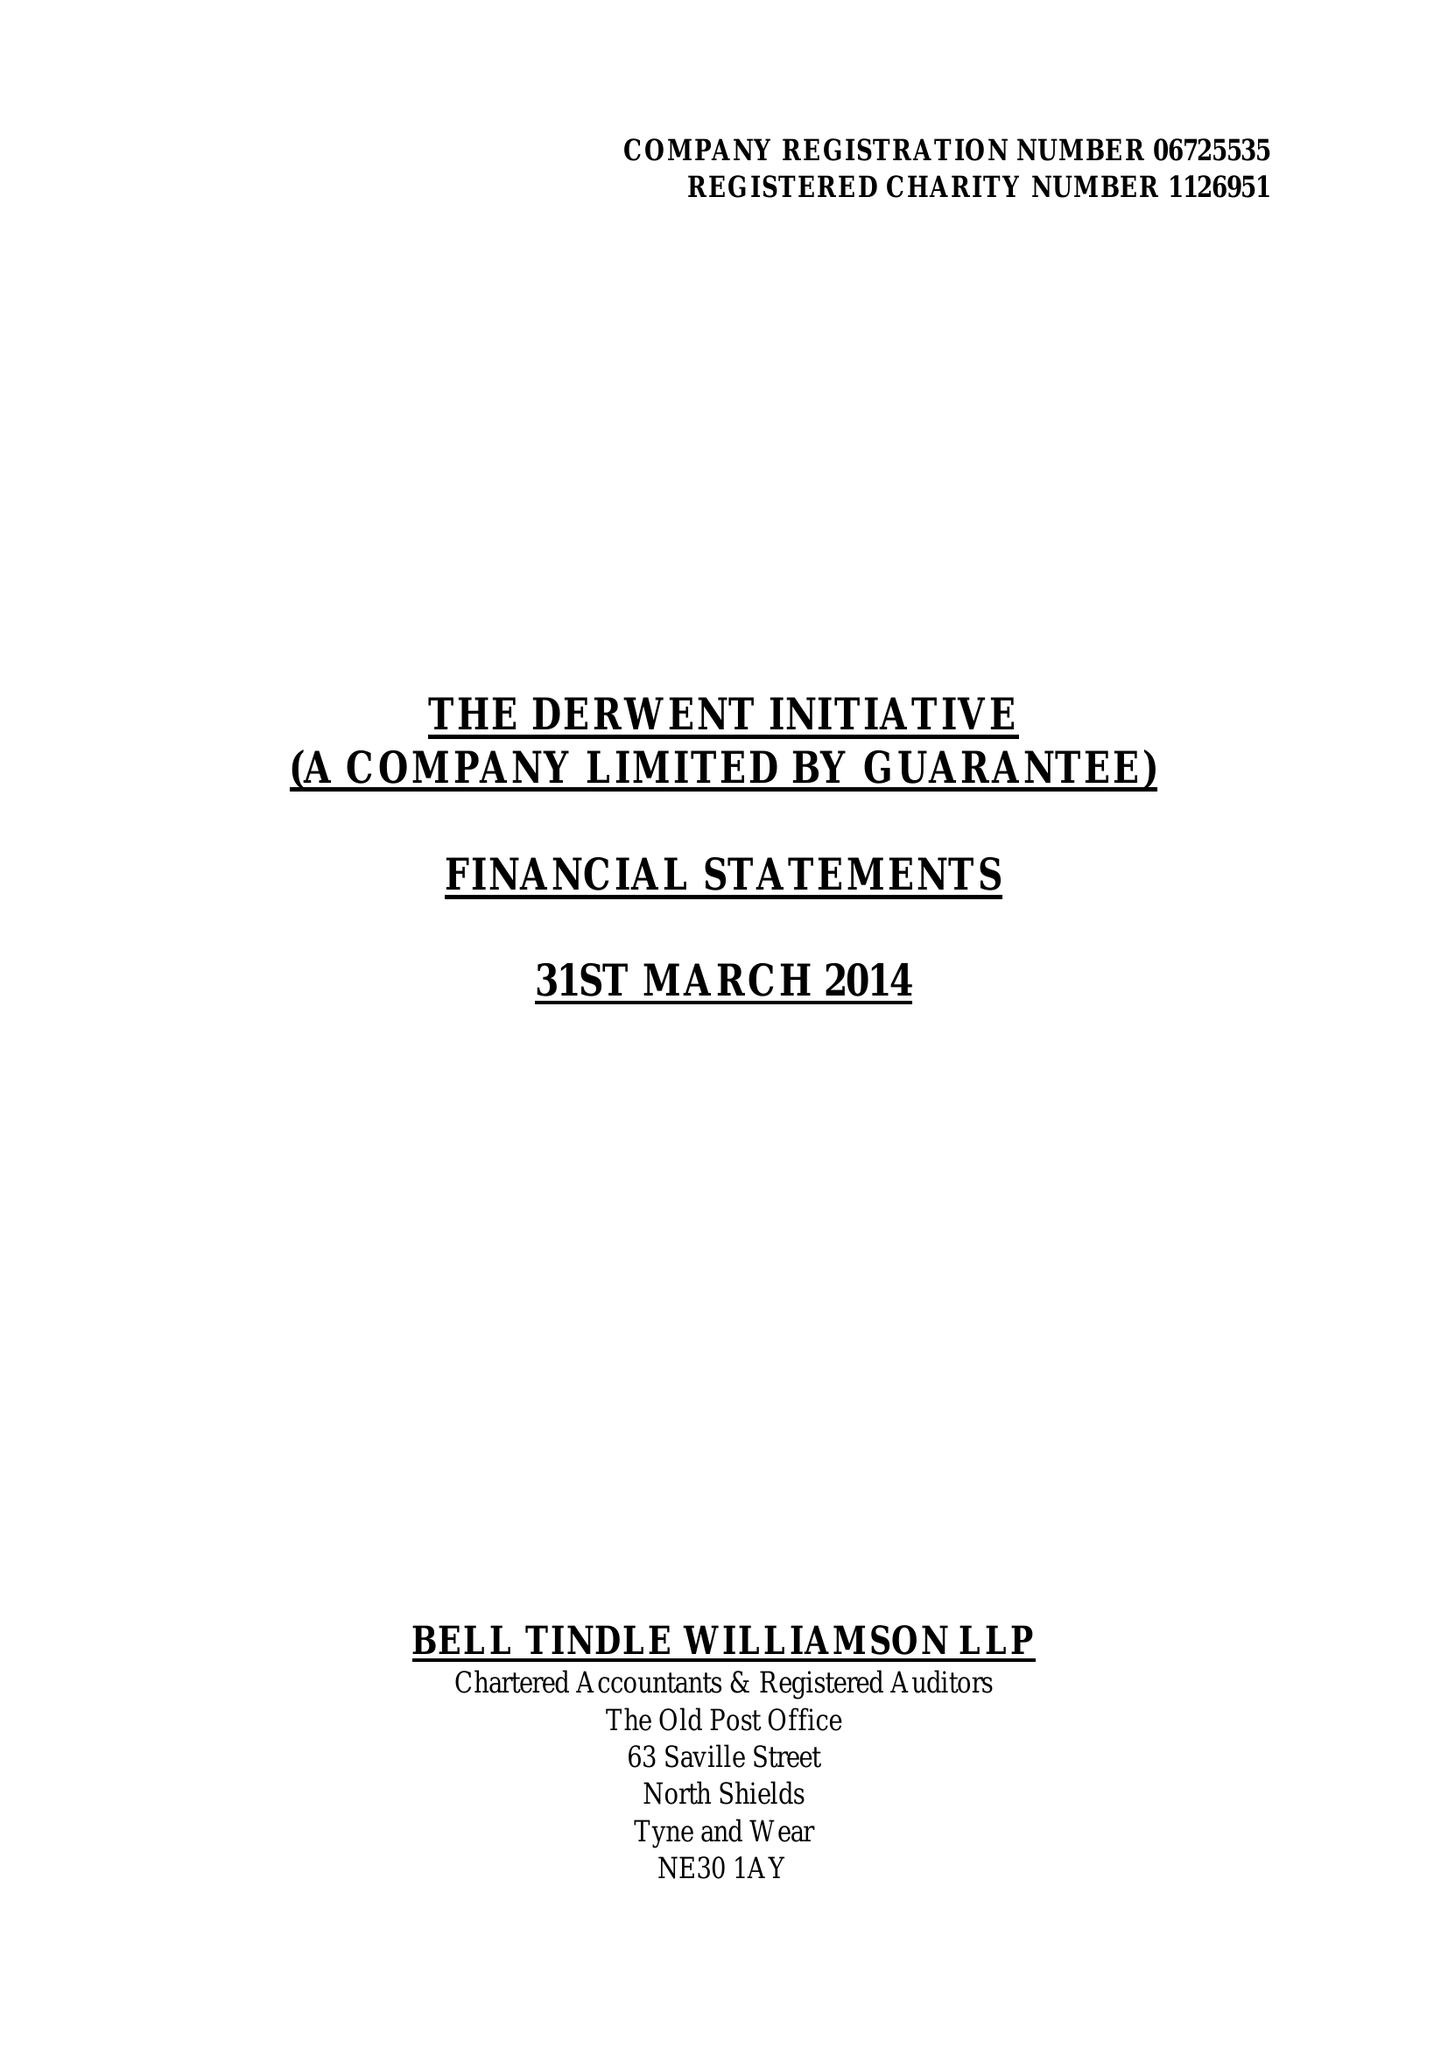What is the value for the income_annually_in_british_pounds?
Answer the question using a single word or phrase. 209668.00 